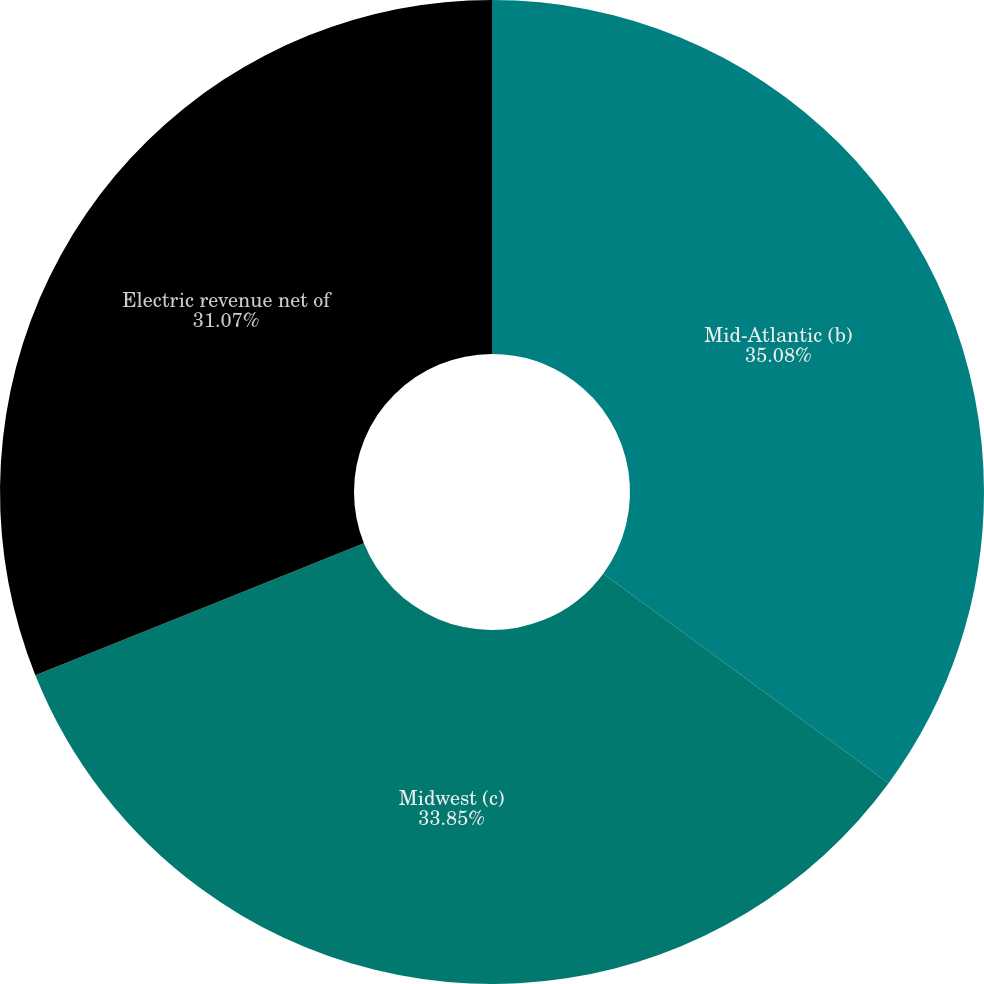Convert chart to OTSL. <chart><loc_0><loc_0><loc_500><loc_500><pie_chart><fcel>Mid-Atlantic (b)<fcel>Midwest (c)<fcel>Electric revenue net of<nl><fcel>35.08%<fcel>33.85%<fcel>31.07%<nl></chart> 